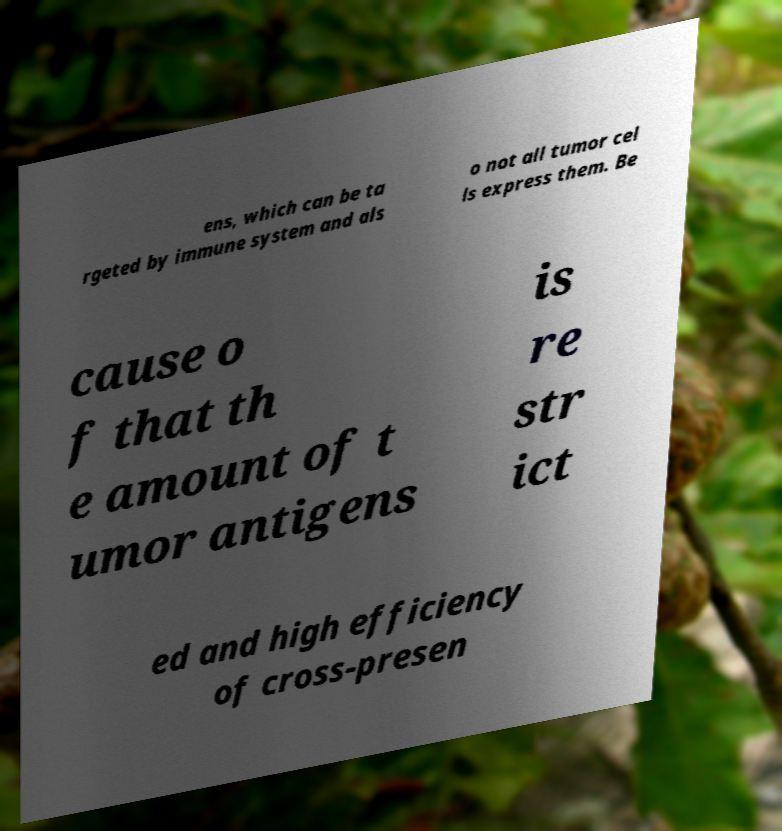Please read and relay the text visible in this image. What does it say? ens, which can be ta rgeted by immune system and als o not all tumor cel ls express them. Be cause o f that th e amount of t umor antigens is re str ict ed and high efficiency of cross-presen 